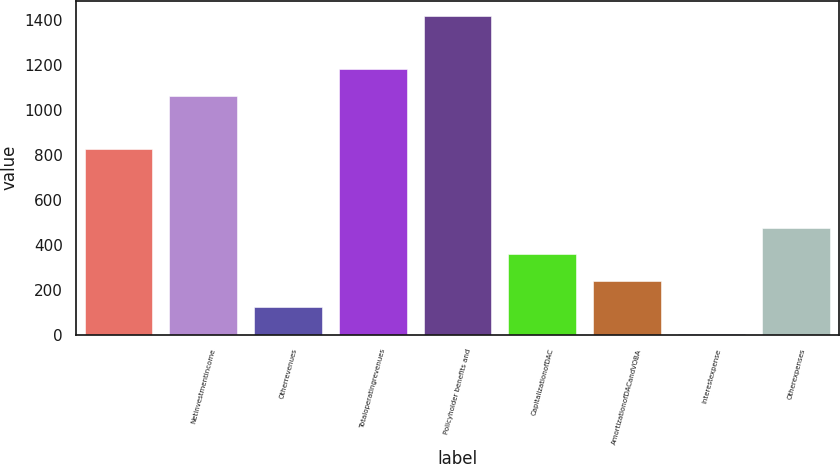Convert chart to OTSL. <chart><loc_0><loc_0><loc_500><loc_500><bar_chart><ecel><fcel>Netinvestmentincome<fcel>Otherrevenues<fcel>Totaloperatingrevenues<fcel>Policyholder benefits and<fcel>CapitalizationofDAC<fcel>AmortizationofDACandVOBA<fcel>Interestexpense<fcel>Otherexpenses<nl><fcel>828.9<fcel>1064.3<fcel>122.7<fcel>1182<fcel>1417.4<fcel>358.1<fcel>240.4<fcel>5<fcel>475.8<nl></chart> 